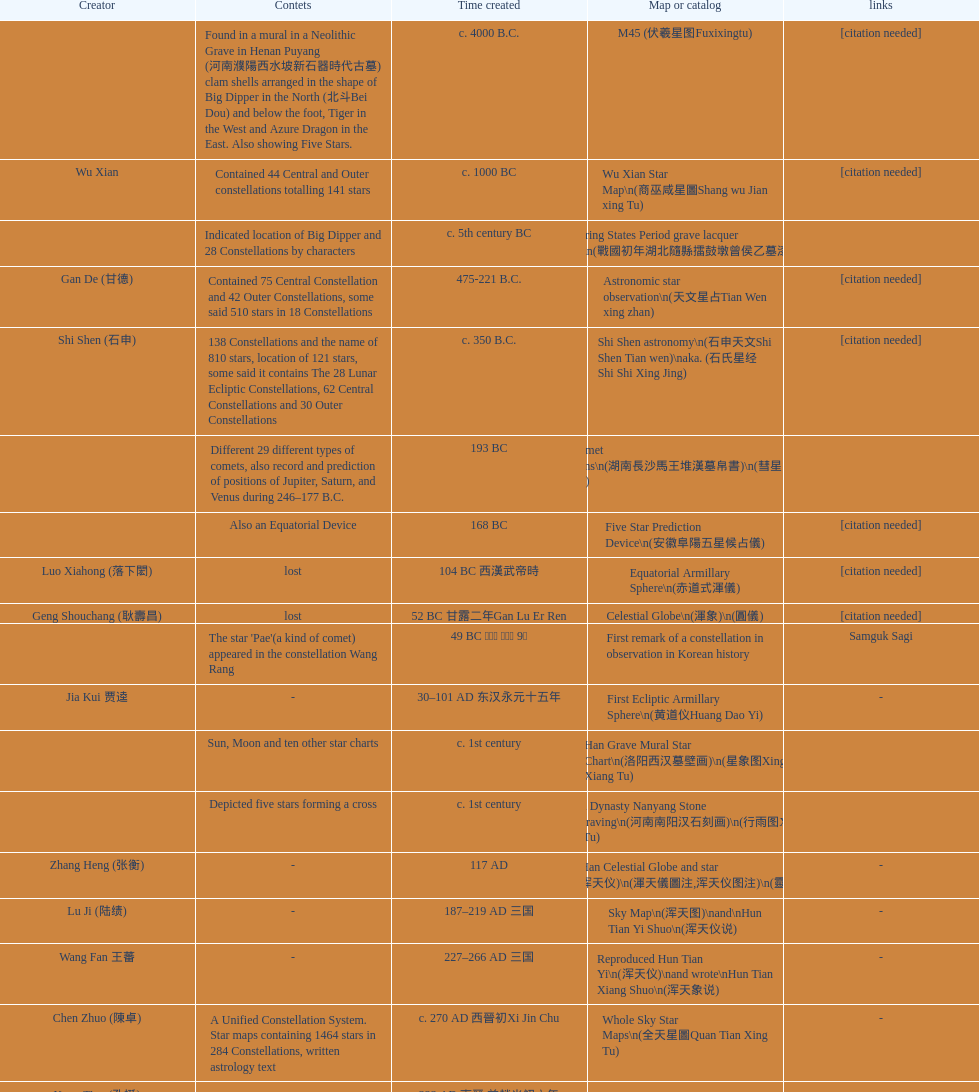Name three items created not long after the equatorial armillary sphere. Celestial Globe (渾象) (圓儀), First remark of a constellation in observation in Korean history, First Ecliptic Armillary Sphere (黄道仪Huang Dao Yi). 